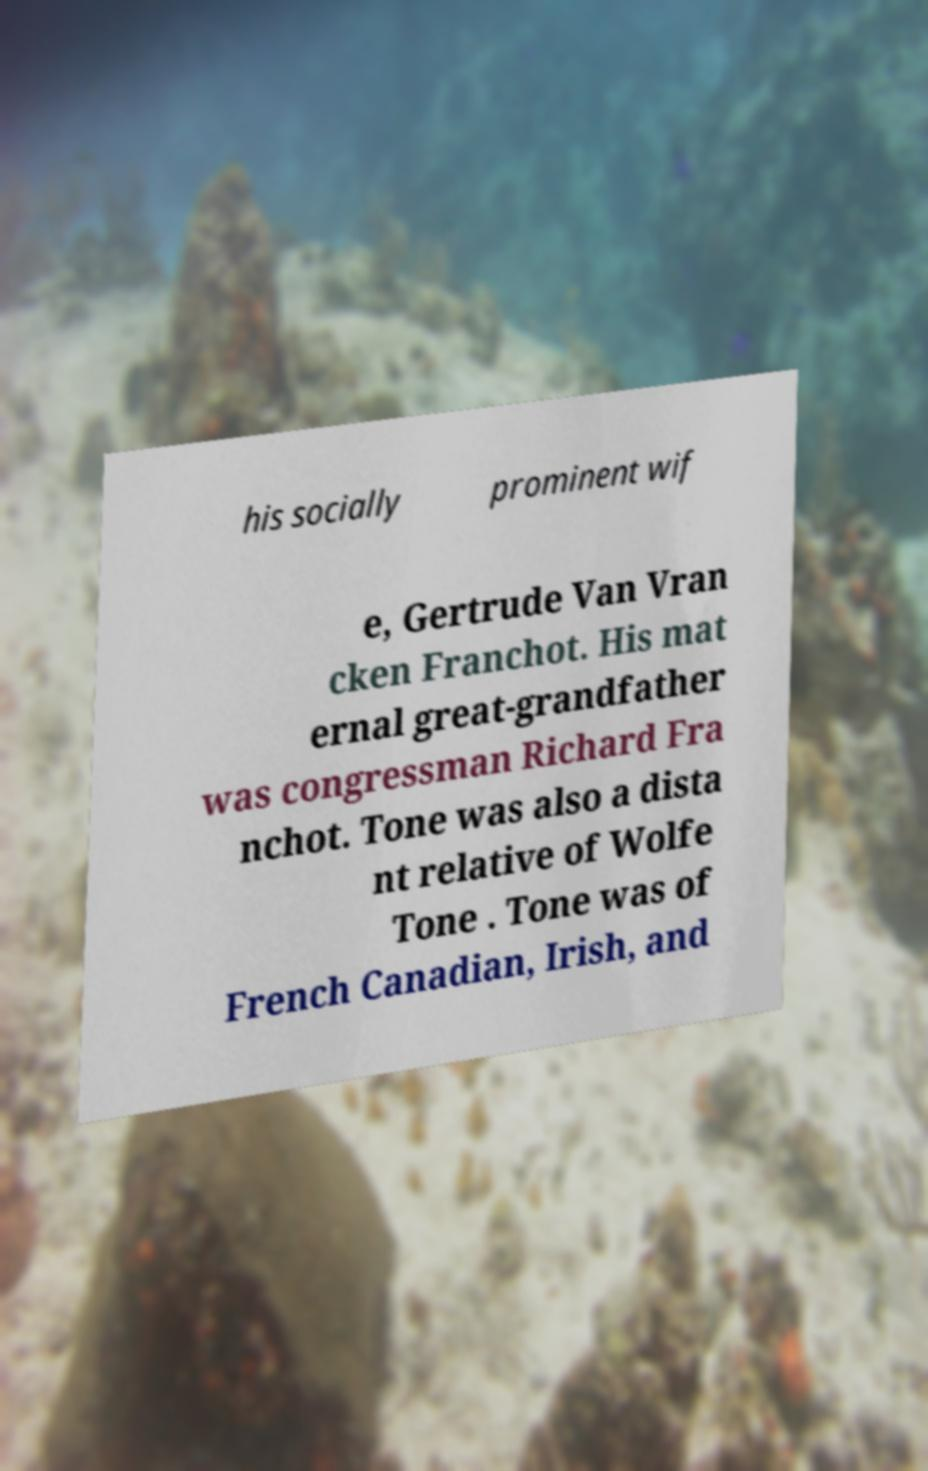I need the written content from this picture converted into text. Can you do that? his socially prominent wif e, Gertrude Van Vran cken Franchot. His mat ernal great-grandfather was congressman Richard Fra nchot. Tone was also a dista nt relative of Wolfe Tone . Tone was of French Canadian, Irish, and 